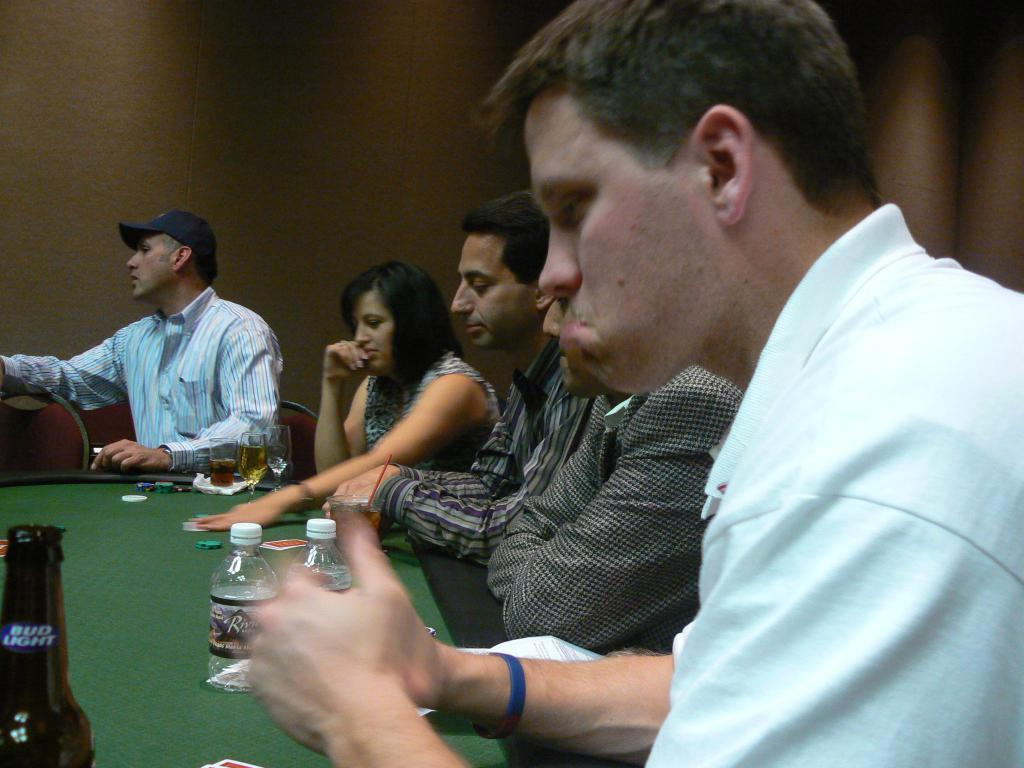What are the persons in the image doing? The persons in the image are sitting on a chair. What objects can be seen on the table in the image? There are bottles and glasses on the table in the image. What type of engine can be seen in the image? There is no engine present in the image. Can you tell me how many experts are visible in the image? A: There is no mention of experts in the image, as it only features persons sitting on a chair and objects on a table. 